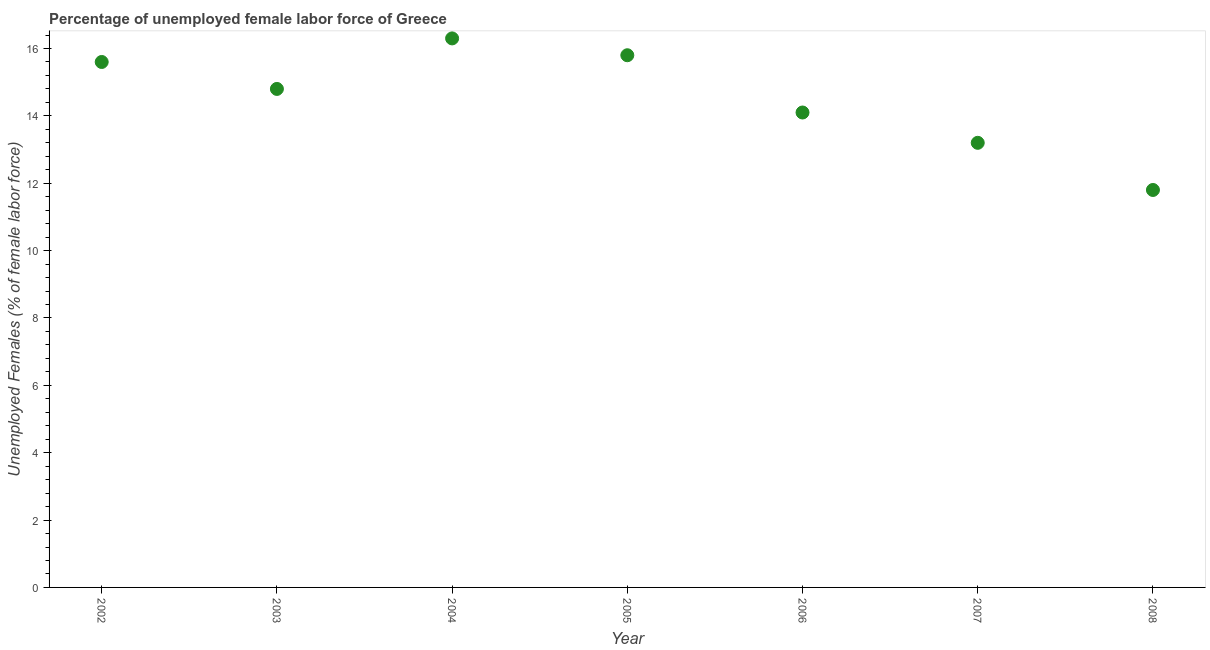What is the total unemployed female labour force in 2008?
Offer a very short reply. 11.8. Across all years, what is the maximum total unemployed female labour force?
Offer a very short reply. 16.3. Across all years, what is the minimum total unemployed female labour force?
Your answer should be compact. 11.8. What is the sum of the total unemployed female labour force?
Provide a succinct answer. 101.6. What is the difference between the total unemployed female labour force in 2004 and 2007?
Your answer should be very brief. 3.1. What is the average total unemployed female labour force per year?
Offer a terse response. 14.51. What is the median total unemployed female labour force?
Your response must be concise. 14.8. In how many years, is the total unemployed female labour force greater than 7.6 %?
Provide a short and direct response. 7. What is the ratio of the total unemployed female labour force in 2006 to that in 2008?
Offer a terse response. 1.19. Is the total unemployed female labour force in 2002 less than that in 2004?
Offer a very short reply. Yes. Is the difference between the total unemployed female labour force in 2005 and 2008 greater than the difference between any two years?
Your response must be concise. No. What is the difference between the highest and the second highest total unemployed female labour force?
Offer a very short reply. 0.5. Is the sum of the total unemployed female labour force in 2003 and 2004 greater than the maximum total unemployed female labour force across all years?
Keep it short and to the point. Yes. What is the difference between the highest and the lowest total unemployed female labour force?
Make the answer very short. 4.5. How many dotlines are there?
Provide a short and direct response. 1. How many years are there in the graph?
Ensure brevity in your answer.  7. Are the values on the major ticks of Y-axis written in scientific E-notation?
Offer a terse response. No. Does the graph contain grids?
Your response must be concise. No. What is the title of the graph?
Offer a very short reply. Percentage of unemployed female labor force of Greece. What is the label or title of the X-axis?
Make the answer very short. Year. What is the label or title of the Y-axis?
Your response must be concise. Unemployed Females (% of female labor force). What is the Unemployed Females (% of female labor force) in 2002?
Your answer should be very brief. 15.6. What is the Unemployed Females (% of female labor force) in 2003?
Make the answer very short. 14.8. What is the Unemployed Females (% of female labor force) in 2004?
Make the answer very short. 16.3. What is the Unemployed Females (% of female labor force) in 2005?
Your answer should be very brief. 15.8. What is the Unemployed Females (% of female labor force) in 2006?
Provide a succinct answer. 14.1. What is the Unemployed Females (% of female labor force) in 2007?
Offer a very short reply. 13.2. What is the Unemployed Females (% of female labor force) in 2008?
Your answer should be very brief. 11.8. What is the difference between the Unemployed Females (% of female labor force) in 2002 and 2003?
Provide a short and direct response. 0.8. What is the difference between the Unemployed Females (% of female labor force) in 2002 and 2006?
Your response must be concise. 1.5. What is the difference between the Unemployed Females (% of female labor force) in 2003 and 2007?
Offer a very short reply. 1.6. What is the difference between the Unemployed Females (% of female labor force) in 2004 and 2006?
Provide a succinct answer. 2.2. What is the difference between the Unemployed Females (% of female labor force) in 2005 and 2008?
Ensure brevity in your answer.  4. What is the difference between the Unemployed Females (% of female labor force) in 2006 and 2008?
Provide a short and direct response. 2.3. What is the difference between the Unemployed Females (% of female labor force) in 2007 and 2008?
Give a very brief answer. 1.4. What is the ratio of the Unemployed Females (% of female labor force) in 2002 to that in 2003?
Offer a very short reply. 1.05. What is the ratio of the Unemployed Females (% of female labor force) in 2002 to that in 2006?
Your response must be concise. 1.11. What is the ratio of the Unemployed Females (% of female labor force) in 2002 to that in 2007?
Your answer should be very brief. 1.18. What is the ratio of the Unemployed Females (% of female labor force) in 2002 to that in 2008?
Offer a very short reply. 1.32. What is the ratio of the Unemployed Females (% of female labor force) in 2003 to that in 2004?
Your response must be concise. 0.91. What is the ratio of the Unemployed Females (% of female labor force) in 2003 to that in 2005?
Offer a terse response. 0.94. What is the ratio of the Unemployed Females (% of female labor force) in 2003 to that in 2007?
Ensure brevity in your answer.  1.12. What is the ratio of the Unemployed Females (% of female labor force) in 2003 to that in 2008?
Make the answer very short. 1.25. What is the ratio of the Unemployed Females (% of female labor force) in 2004 to that in 2005?
Provide a succinct answer. 1.03. What is the ratio of the Unemployed Females (% of female labor force) in 2004 to that in 2006?
Make the answer very short. 1.16. What is the ratio of the Unemployed Females (% of female labor force) in 2004 to that in 2007?
Your response must be concise. 1.24. What is the ratio of the Unemployed Females (% of female labor force) in 2004 to that in 2008?
Provide a short and direct response. 1.38. What is the ratio of the Unemployed Females (% of female labor force) in 2005 to that in 2006?
Your answer should be compact. 1.12. What is the ratio of the Unemployed Females (% of female labor force) in 2005 to that in 2007?
Provide a succinct answer. 1.2. What is the ratio of the Unemployed Females (% of female labor force) in 2005 to that in 2008?
Give a very brief answer. 1.34. What is the ratio of the Unemployed Females (% of female labor force) in 2006 to that in 2007?
Give a very brief answer. 1.07. What is the ratio of the Unemployed Females (% of female labor force) in 2006 to that in 2008?
Ensure brevity in your answer.  1.2. What is the ratio of the Unemployed Females (% of female labor force) in 2007 to that in 2008?
Provide a succinct answer. 1.12. 